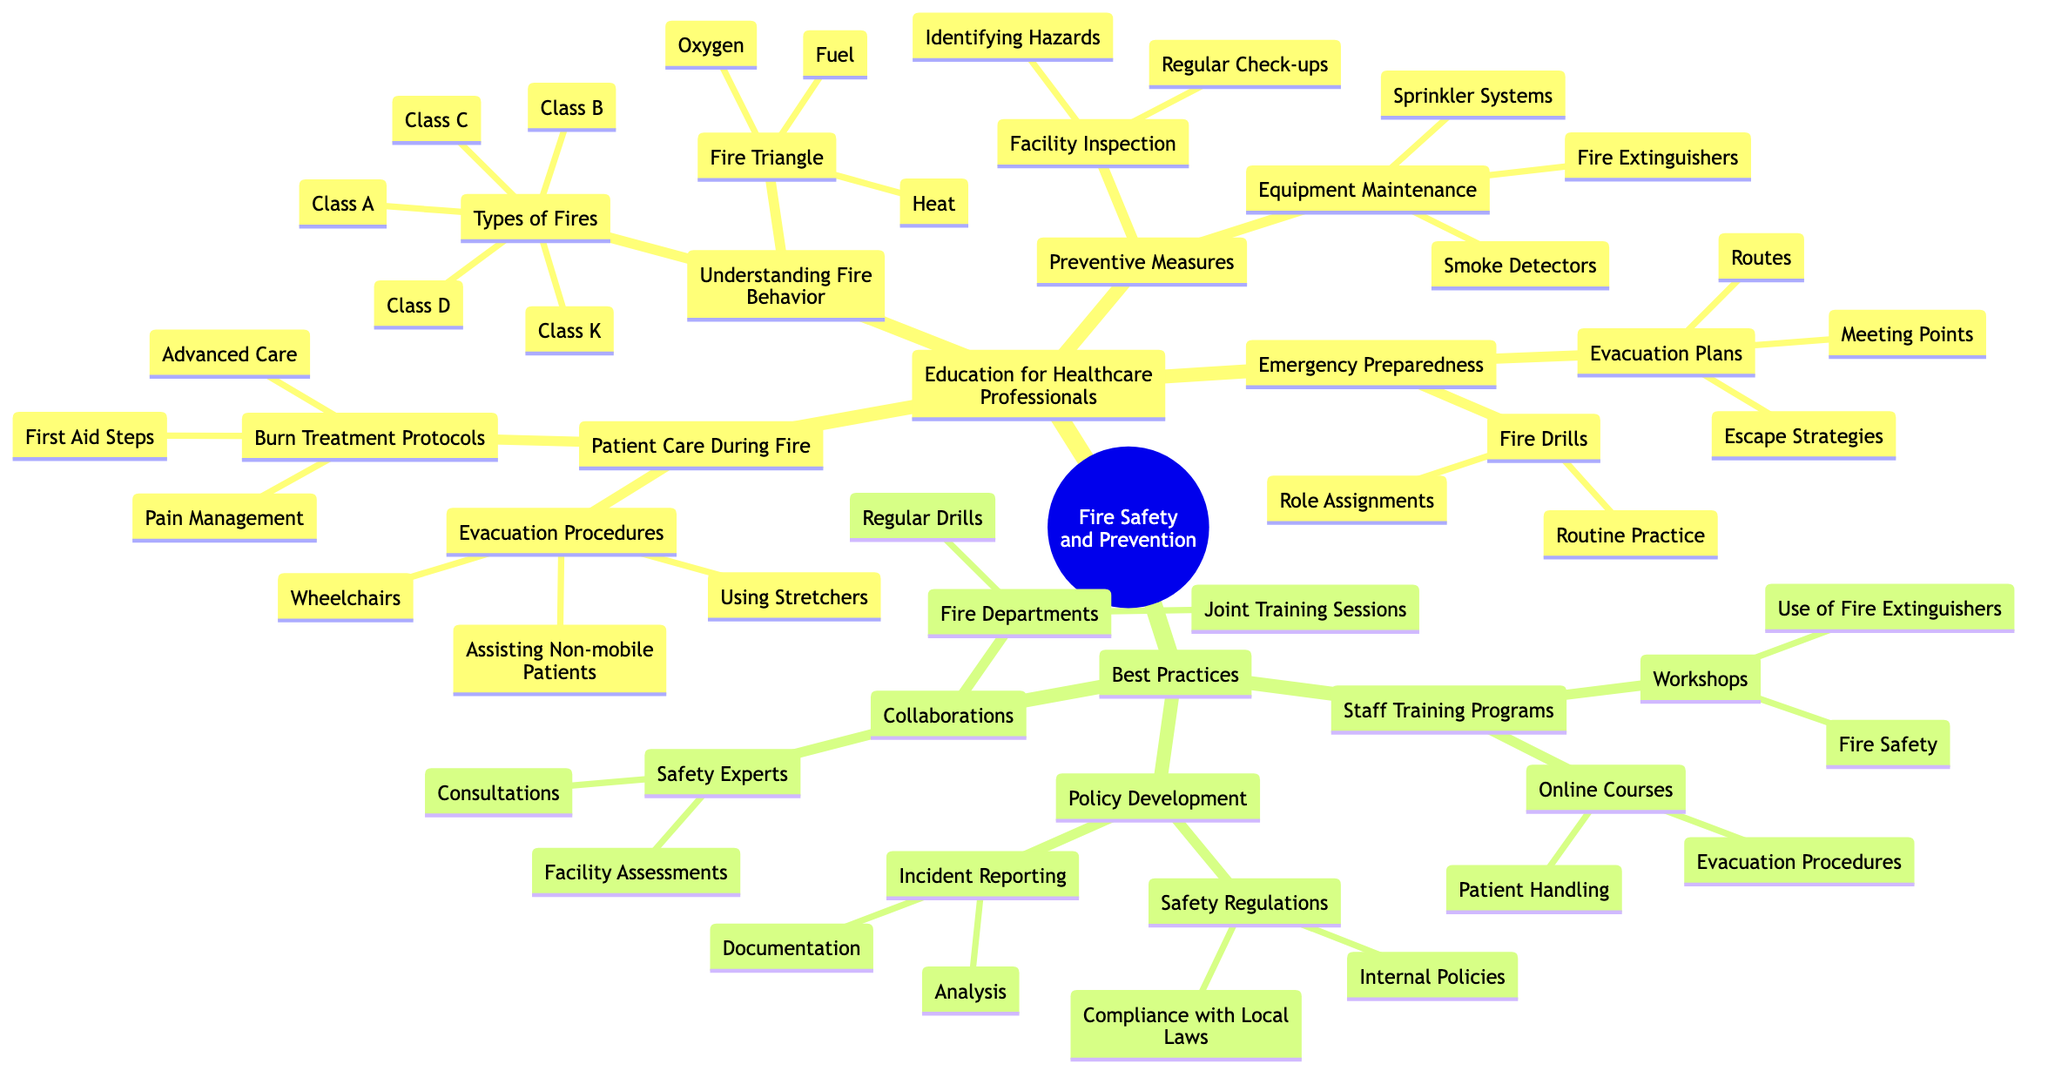What are the types of fires listed in the diagram? The diagram lists five types of fires under the "Types of Fires" section: Class A, Class B, Class C, Class D, and Class K.
Answer: Class A, Class B, Class C, Class D, Class K How many preventive measures are outlined in the diagram? The diagram specifies two main categories of preventive measures: "Facility Inspection" and "Equipment Maintenance", hence there are two main preventive measures.
Answer: 2 What key components make up the fire triangle according to the diagram? The diagram identifies three key components of the fire triangle: Heat, Fuel, and Oxygen.
Answer: Heat, Fuel, Oxygen What strategies are included in emergency preparedness? The diagram outlines two main strategies for emergency preparedness: "Evacuation Plans" and "Fire Drills."
Answer: Evacuation Plans, Fire Drills How many types of staff training programs are mentioned in best practices? The diagram includes two types of staff training programs: "Workshops" and "Online Courses". Therefore, there are two types mentioned.
Answer: 2 How do "Collaborations" contribute to fire safety according to the diagram? The "Collaborations" section lists two groups: "Fire Departments" and "Safety Experts," along with tasks associated with each, showing the importance of cooperation in fire safety measures.
Answer: Fire Departments, Safety Experts Which aspect of patient care is emphasized during a fire situation? The diagram emphasizes "Evacuation Procedures" and "Burn Treatment Protocols" as critical aspects of patient care during a fire.
Answer: Evacuation Procedures, Burn Treatment Protocols What is listed under "Incident Reporting" in the policy development section? The "Incident Reporting" section specifies two key activities: "Documentation" and "Analysis," essential for evaluating fire incidents.
Answer: Documentation, Analysis 